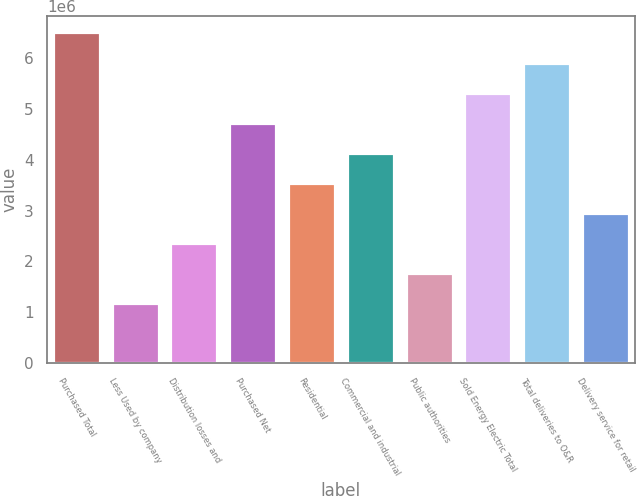Convert chart to OTSL. <chart><loc_0><loc_0><loc_500><loc_500><bar_chart><fcel>Purchased Total<fcel>Less Used by company<fcel>Distribution losses and<fcel>Purchased Net<fcel>Residential<fcel>Commercial and industrial<fcel>Public authorities<fcel>Sold Energy Electric Total<fcel>Total deliveries to O&R<fcel>Delivery service for retail<nl><fcel>6.50273e+06<fcel>1.18233e+06<fcel>2.36464e+06<fcel>4.72926e+06<fcel>3.54695e+06<fcel>4.13811e+06<fcel>1.77348e+06<fcel>5.32042e+06<fcel>5.91158e+06<fcel>2.95579e+06<nl></chart> 